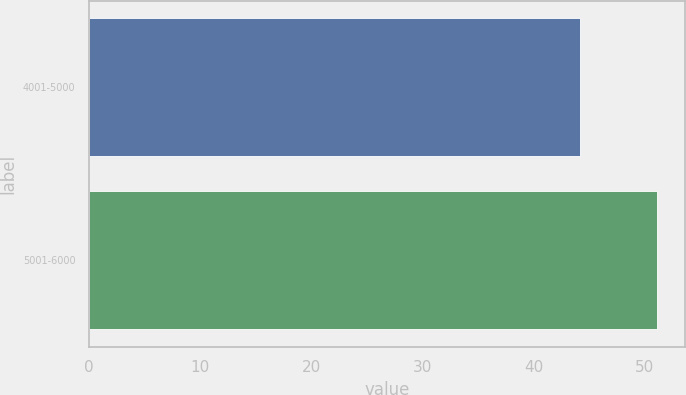<chart> <loc_0><loc_0><loc_500><loc_500><bar_chart><fcel>4001-5000<fcel>5001-6000<nl><fcel>44.13<fcel>51.08<nl></chart> 